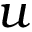<formula> <loc_0><loc_0><loc_500><loc_500>u</formula> 